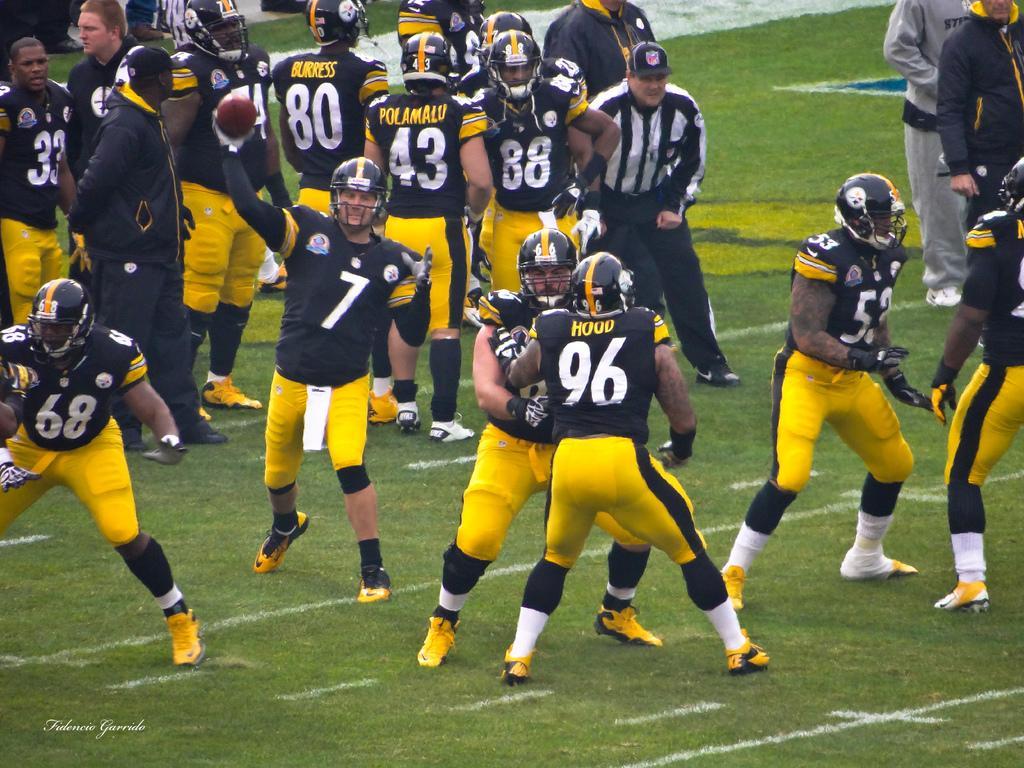Could you give a brief overview of what you see in this image? In this image I can see a group of baseball players, they wore black color t-shirts, yellow color trousers and black color helmets. In the middle a man is holding the baseball and here a man is standing, he wore a black color trouser, black and white shirt. 